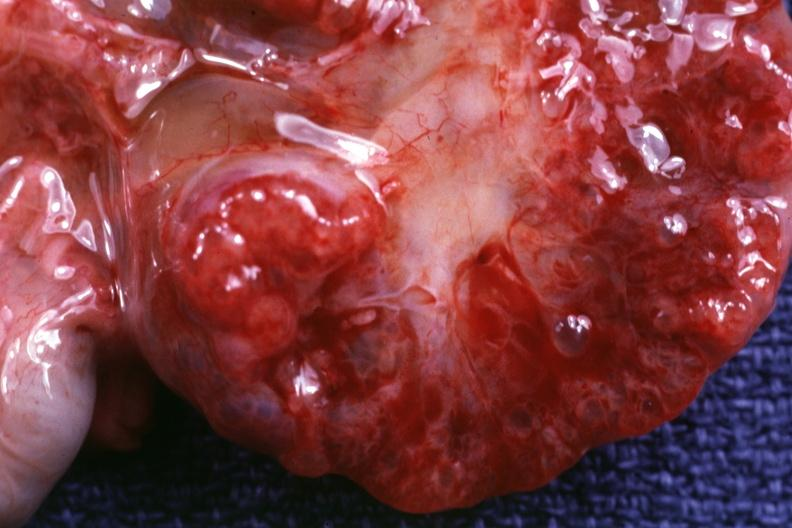where is this?
Answer the question using a single word or phrase. Urinary 